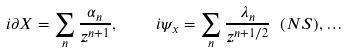Convert formula to latex. <formula><loc_0><loc_0><loc_500><loc_500>i \partial X = \sum _ { n } { \frac { \alpha _ { n } } { z ^ { n + 1 } } } , \quad i \psi _ { x } = \sum _ { n } { \frac { \lambda _ { n } } { z ^ { n + 1 / 2 } } } \ ( N S ) , \dots</formula> 